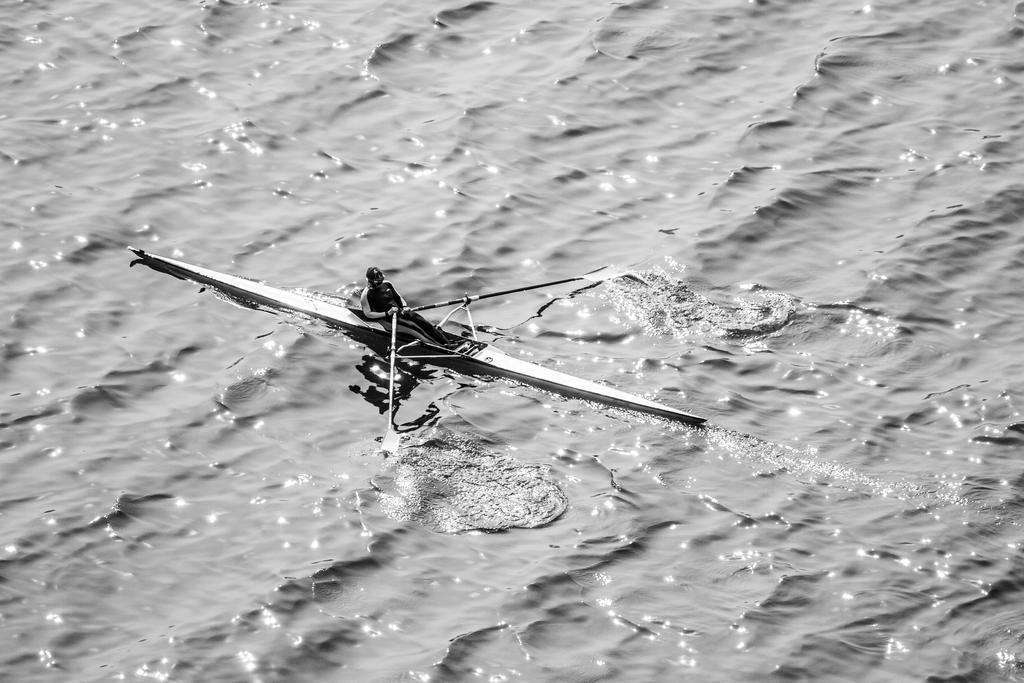What is the color scheme of the image? The image is black and white. Can you describe the main subject in the image? There is a person in the image. What is the person doing in the image? The person is riding a boat. Where is the boat located in the image? The boat is in water. Where can the shelf be seen in the image? There is no shelf present in the image. What type of machine is being operated by the person in the image? There is no machine present in the image; the person is riding a boat. 